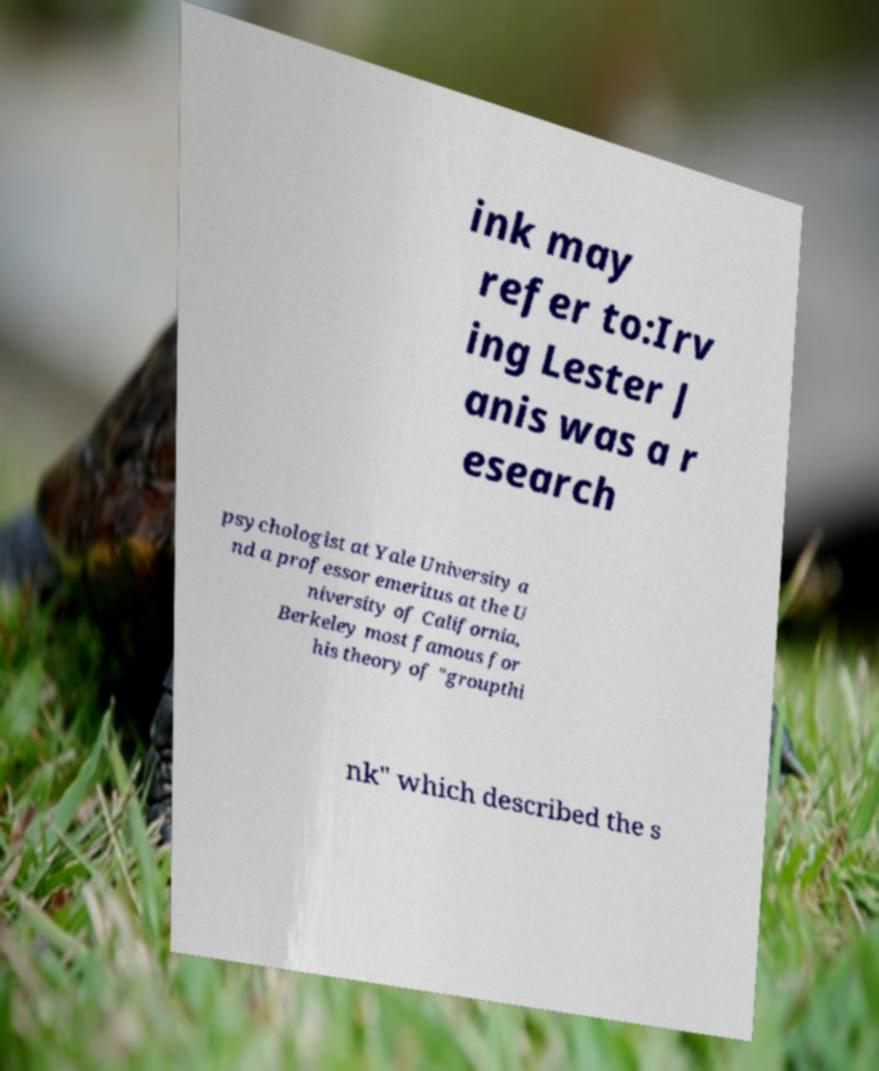Please identify and transcribe the text found in this image. ink may refer to:Irv ing Lester J anis was a r esearch psychologist at Yale University a nd a professor emeritus at the U niversity of California, Berkeley most famous for his theory of "groupthi nk" which described the s 